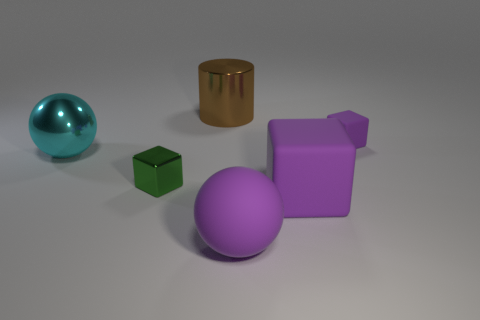Is the small cube left of the small purple cube made of the same material as the large purple block?
Provide a short and direct response. No. The metal object to the left of the small object that is to the left of the purple ball that is in front of the large block is what shape?
Your response must be concise. Sphere. Are there an equal number of big purple things behind the green metallic thing and small green things in front of the small purple thing?
Offer a very short reply. No. There is a matte block that is the same size as the green thing; what color is it?
Provide a succinct answer. Purple. How many tiny objects are either cyan shiny cubes or brown objects?
Offer a very short reply. 0. There is a big thing that is behind the tiny green metal cube and in front of the brown cylinder; what material is it?
Your answer should be compact. Metal. Do the large metal thing that is in front of the tiny purple matte thing and the brown thing that is left of the small purple matte thing have the same shape?
Offer a terse response. No. What is the shape of the big object that is the same color as the big cube?
Make the answer very short. Sphere. How many objects are cubes that are to the right of the purple rubber ball or large yellow spheres?
Provide a succinct answer. 2. Is the purple matte ball the same size as the green cube?
Keep it short and to the point. No. 